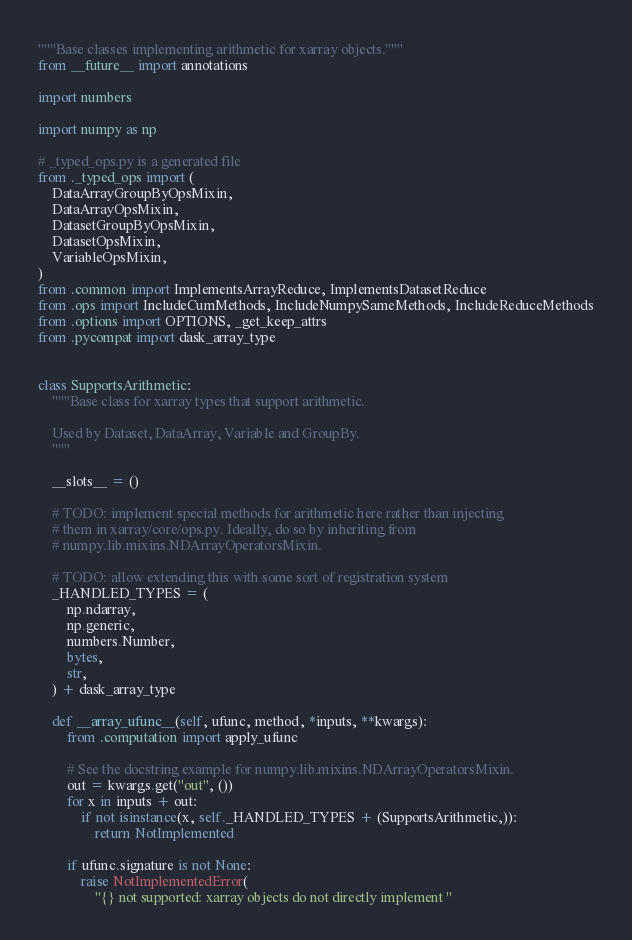<code> <loc_0><loc_0><loc_500><loc_500><_Python_>"""Base classes implementing arithmetic for xarray objects."""
from __future__ import annotations

import numbers

import numpy as np

# _typed_ops.py is a generated file
from ._typed_ops import (
    DataArrayGroupByOpsMixin,
    DataArrayOpsMixin,
    DatasetGroupByOpsMixin,
    DatasetOpsMixin,
    VariableOpsMixin,
)
from .common import ImplementsArrayReduce, ImplementsDatasetReduce
from .ops import IncludeCumMethods, IncludeNumpySameMethods, IncludeReduceMethods
from .options import OPTIONS, _get_keep_attrs
from .pycompat import dask_array_type


class SupportsArithmetic:
    """Base class for xarray types that support arithmetic.

    Used by Dataset, DataArray, Variable and GroupBy.
    """

    __slots__ = ()

    # TODO: implement special methods for arithmetic here rather than injecting
    # them in xarray/core/ops.py. Ideally, do so by inheriting from
    # numpy.lib.mixins.NDArrayOperatorsMixin.

    # TODO: allow extending this with some sort of registration system
    _HANDLED_TYPES = (
        np.ndarray,
        np.generic,
        numbers.Number,
        bytes,
        str,
    ) + dask_array_type

    def __array_ufunc__(self, ufunc, method, *inputs, **kwargs):
        from .computation import apply_ufunc

        # See the docstring example for numpy.lib.mixins.NDArrayOperatorsMixin.
        out = kwargs.get("out", ())
        for x in inputs + out:
            if not isinstance(x, self._HANDLED_TYPES + (SupportsArithmetic,)):
                return NotImplemented

        if ufunc.signature is not None:
            raise NotImplementedError(
                "{} not supported: xarray objects do not directly implement "</code> 